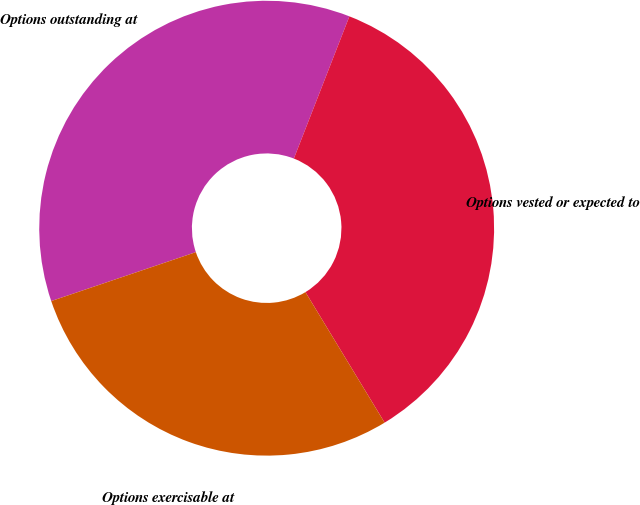Convert chart. <chart><loc_0><loc_0><loc_500><loc_500><pie_chart><fcel>Options outstanding at<fcel>Options vested or expected to<fcel>Options exercisable at<nl><fcel>36.12%<fcel>35.4%<fcel>28.49%<nl></chart> 